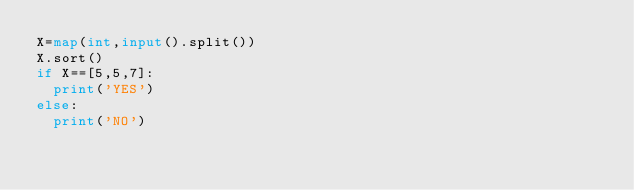<code> <loc_0><loc_0><loc_500><loc_500><_Python_>X=map(int,input().split())
X.sort()
if X==[5,5,7]:
  print('YES')
else:
  print('NO')</code> 